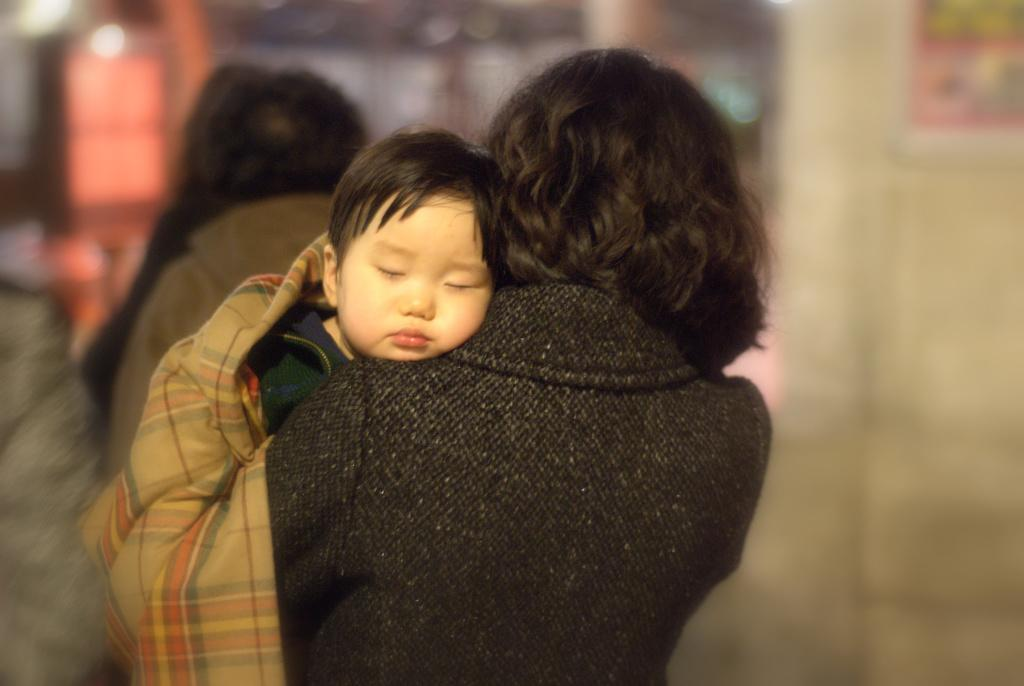What is the person in the image doing? The person is holding a baby in the image. What is the person wearing? The person is wearing a black dress. Can you describe the background of the image? The background of the image is blurred. What type of sign can be seen in the baby's hand in the image? There is no sign visible in the baby's hand in the image. What is the person's nose doing in the image? The person's nose is not doing anything in the image; it is simply part of the person's face. 